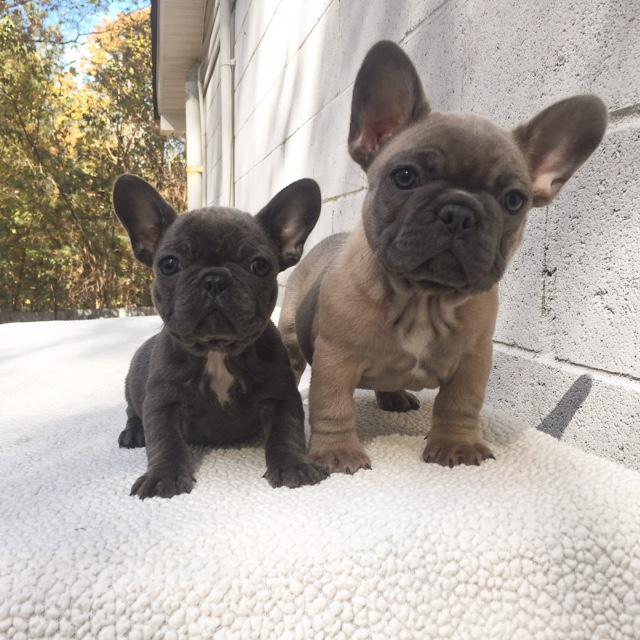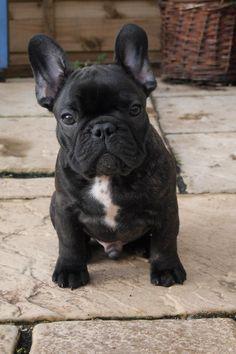The first image is the image on the left, the second image is the image on the right. Examine the images to the left and right. Is the description "There are three dogs." accurate? Answer yes or no. Yes. The first image is the image on the left, the second image is the image on the right. Evaluate the accuracy of this statement regarding the images: "One image includes exactly twice as many big-eared dogs in the foreground as the other image.". Is it true? Answer yes or no. Yes. 